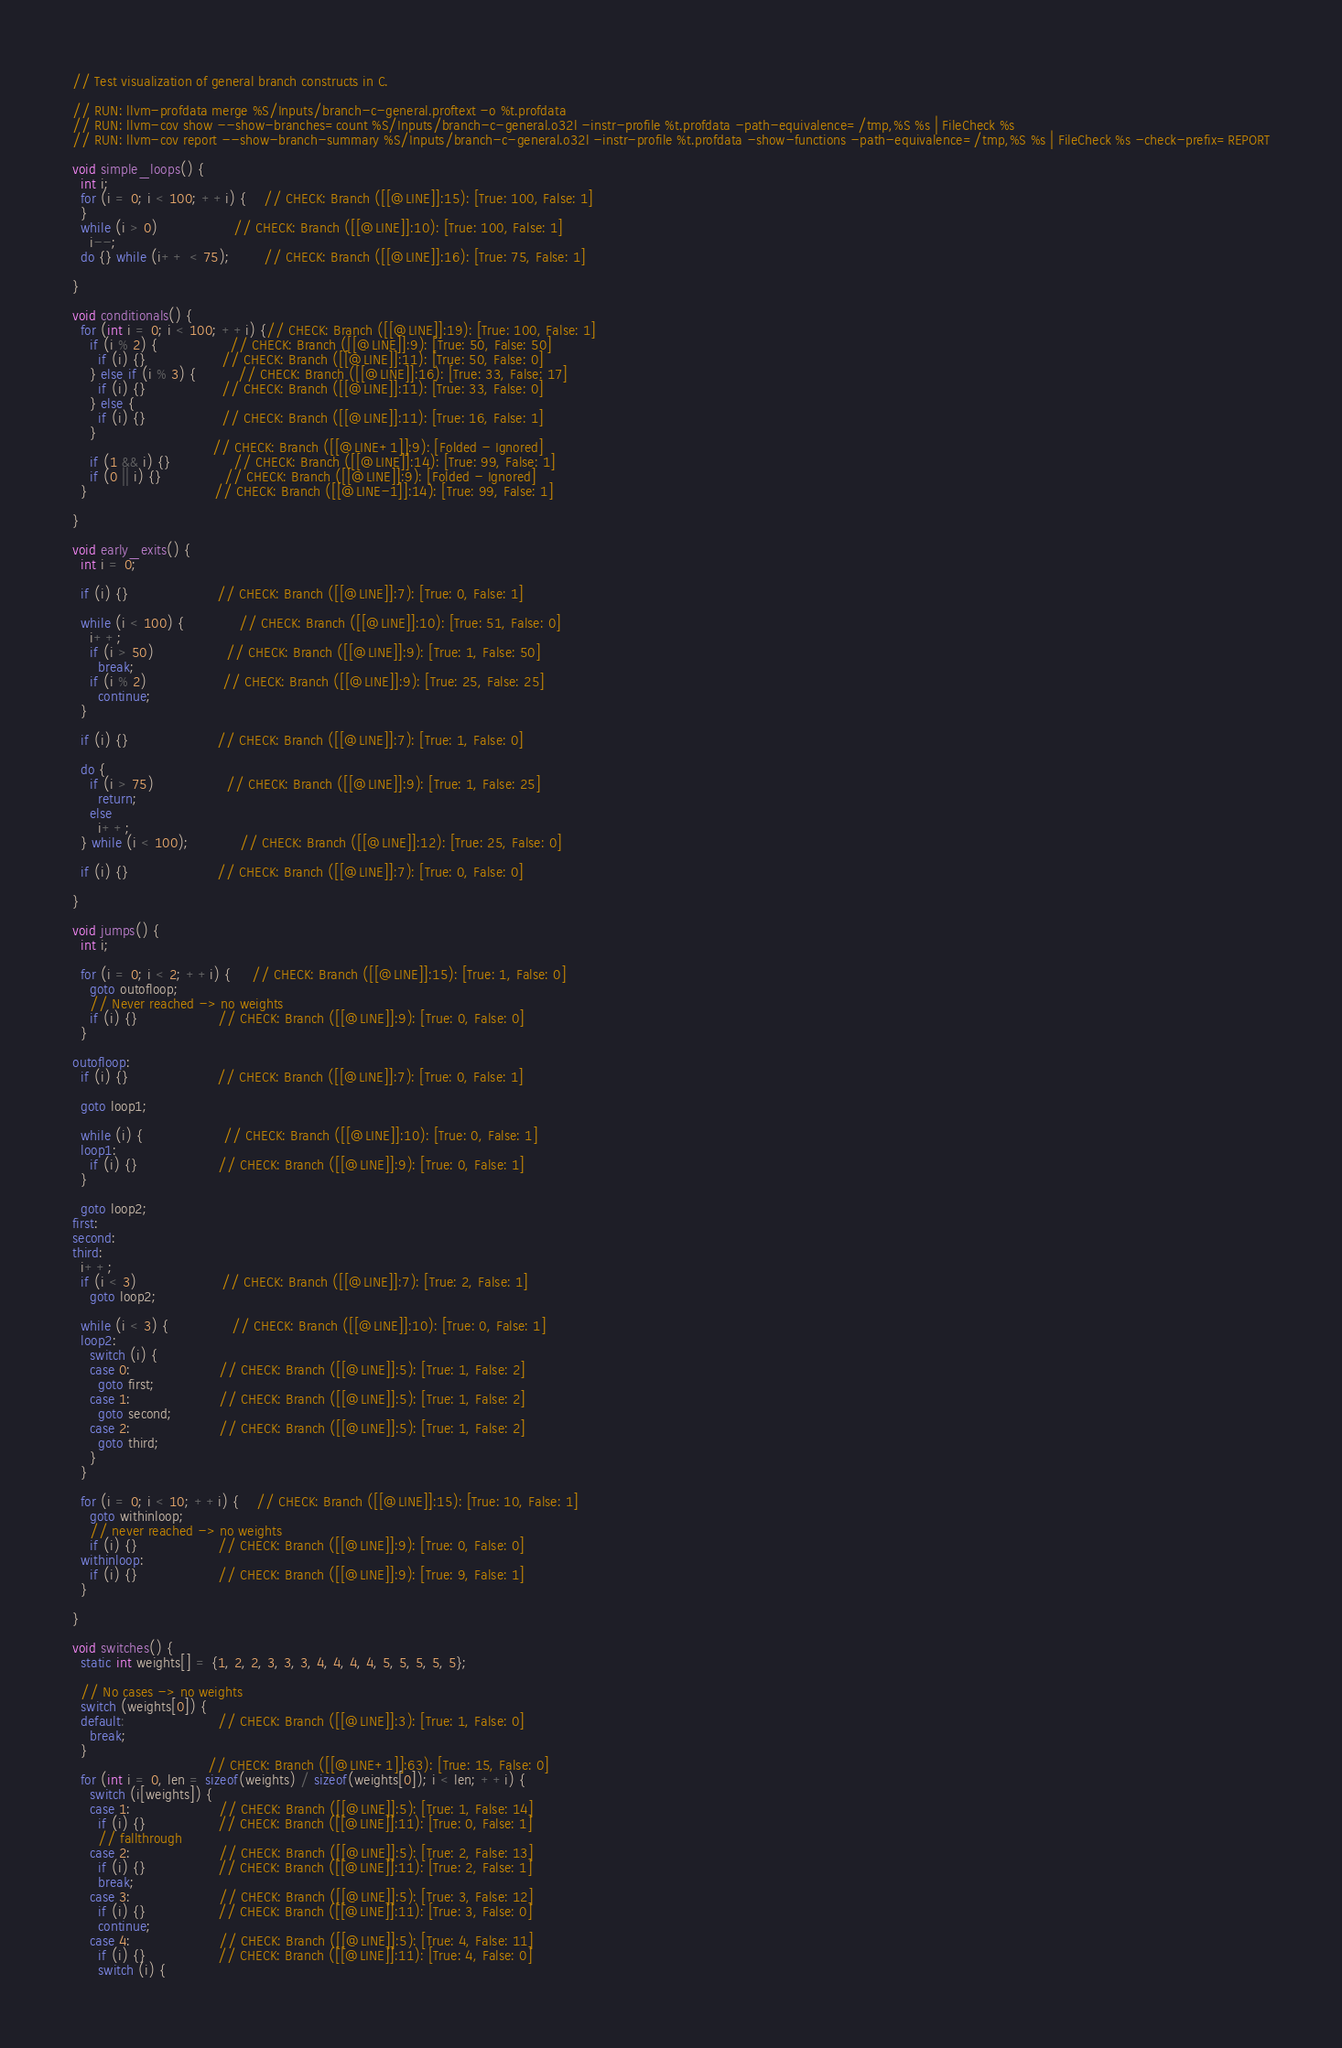<code> <loc_0><loc_0><loc_500><loc_500><_C_>// Test visualization of general branch constructs in C.

// RUN: llvm-profdata merge %S/Inputs/branch-c-general.proftext -o %t.profdata
// RUN: llvm-cov show --show-branches=count %S/Inputs/branch-c-general.o32l -instr-profile %t.profdata -path-equivalence=/tmp,%S %s | FileCheck %s
// RUN: llvm-cov report --show-branch-summary %S/Inputs/branch-c-general.o32l -instr-profile %t.profdata -show-functions -path-equivalence=/tmp,%S %s | FileCheck %s -check-prefix=REPORT

void simple_loops() {
  int i;
  for (i = 0; i < 100; ++i) {    // CHECK: Branch ([[@LINE]]:15): [True: 100, False: 1]
  }
  while (i > 0)                  // CHECK: Branch ([[@LINE]]:10): [True: 100, False: 1]
    i--;
  do {} while (i++ < 75);        // CHECK: Branch ([[@LINE]]:16): [True: 75, False: 1]

}

void conditionals() {
  for (int i = 0; i < 100; ++i) {// CHECK: Branch ([[@LINE]]:19): [True: 100, False: 1]
    if (i % 2) {                 // CHECK: Branch ([[@LINE]]:9): [True: 50, False: 50]
      if (i) {}                  // CHECK: Branch ([[@LINE]]:11): [True: 50, False: 0]
    } else if (i % 3) {          // CHECK: Branch ([[@LINE]]:16): [True: 33, False: 17]
      if (i) {}                  // CHECK: Branch ([[@LINE]]:11): [True: 33, False: 0]
    } else {
      if (i) {}                  // CHECK: Branch ([[@LINE]]:11): [True: 16, False: 1]
    }
                                 // CHECK: Branch ([[@LINE+1]]:9): [Folded - Ignored]
    if (1 && i) {}               // CHECK: Branch ([[@LINE]]:14): [True: 99, False: 1]
    if (0 || i) {}               // CHECK: Branch ([[@LINE]]:9): [Folded - Ignored]
  }                              // CHECK: Branch ([[@LINE-1]]:14): [True: 99, False: 1]

}

void early_exits() {
  int i = 0;

  if (i) {}                     // CHECK: Branch ([[@LINE]]:7): [True: 0, False: 1]

  while (i < 100) {             // CHECK: Branch ([[@LINE]]:10): [True: 51, False: 0]
    i++;
    if (i > 50)                 // CHECK: Branch ([[@LINE]]:9): [True: 1, False: 50]
      break;
    if (i % 2)                  // CHECK: Branch ([[@LINE]]:9): [True: 25, False: 25]
      continue;
  }

  if (i) {}                     // CHECK: Branch ([[@LINE]]:7): [True: 1, False: 0]

  do {
    if (i > 75)                 // CHECK: Branch ([[@LINE]]:9): [True: 1, False: 25]
      return;
    else
      i++;
  } while (i < 100);            // CHECK: Branch ([[@LINE]]:12): [True: 25, False: 0]

  if (i) {}                     // CHECK: Branch ([[@LINE]]:7): [True: 0, False: 0]

}

void jumps() {
  int i;

  for (i = 0; i < 2; ++i) {     // CHECK: Branch ([[@LINE]]:15): [True: 1, False: 0]
    goto outofloop;
    // Never reached -> no weights
    if (i) {}                   // CHECK: Branch ([[@LINE]]:9): [True: 0, False: 0]
  }

outofloop:
  if (i) {}                     // CHECK: Branch ([[@LINE]]:7): [True: 0, False: 1]

  goto loop1;

  while (i) {                   // CHECK: Branch ([[@LINE]]:10): [True: 0, False: 1]
  loop1:
    if (i) {}                   // CHECK: Branch ([[@LINE]]:9): [True: 0, False: 1]
  }

  goto loop2;
first:
second:
third:
  i++;
  if (i < 3)                    // CHECK: Branch ([[@LINE]]:7): [True: 2, False: 1]
    goto loop2;

  while (i < 3) {               // CHECK: Branch ([[@LINE]]:10): [True: 0, False: 1]
  loop2:
    switch (i) {
    case 0:                     // CHECK: Branch ([[@LINE]]:5): [True: 1, False: 2]
      goto first;
    case 1:                     // CHECK: Branch ([[@LINE]]:5): [True: 1, False: 2]
      goto second;
    case 2:                     // CHECK: Branch ([[@LINE]]:5): [True: 1, False: 2]
      goto third;
    }
  }

  for (i = 0; i < 10; ++i) {    // CHECK: Branch ([[@LINE]]:15): [True: 10, False: 1]
    goto withinloop;
    // never reached -> no weights
    if (i) {}                   // CHECK: Branch ([[@LINE]]:9): [True: 0, False: 0]
  withinloop:
    if (i) {}                   // CHECK: Branch ([[@LINE]]:9): [True: 9, False: 1]
  }

}

void switches() {
  static int weights[] = {1, 2, 2, 3, 3, 3, 4, 4, 4, 4, 5, 5, 5, 5, 5};

  // No cases -> no weights
  switch (weights[0]) {
  default:                      // CHECK: Branch ([[@LINE]]:3): [True: 1, False: 0]
    break;
  }
                                // CHECK: Branch ([[@LINE+1]]:63): [True: 15, False: 0]
  for (int i = 0, len = sizeof(weights) / sizeof(weights[0]); i < len; ++i) {
    switch (i[weights]) {
    case 1:                     // CHECK: Branch ([[@LINE]]:5): [True: 1, False: 14]
      if (i) {}                 // CHECK: Branch ([[@LINE]]:11): [True: 0, False: 1]
      // fallthrough
    case 2:                     // CHECK: Branch ([[@LINE]]:5): [True: 2, False: 13]
      if (i) {}                 // CHECK: Branch ([[@LINE]]:11): [True: 2, False: 1]
      break;
    case 3:                     // CHECK: Branch ([[@LINE]]:5): [True: 3, False: 12]
      if (i) {}                 // CHECK: Branch ([[@LINE]]:11): [True: 3, False: 0]
      continue;
    case 4:                     // CHECK: Branch ([[@LINE]]:5): [True: 4, False: 11]
      if (i) {}                 // CHECK: Branch ([[@LINE]]:11): [True: 4, False: 0]
      switch (i) {</code> 